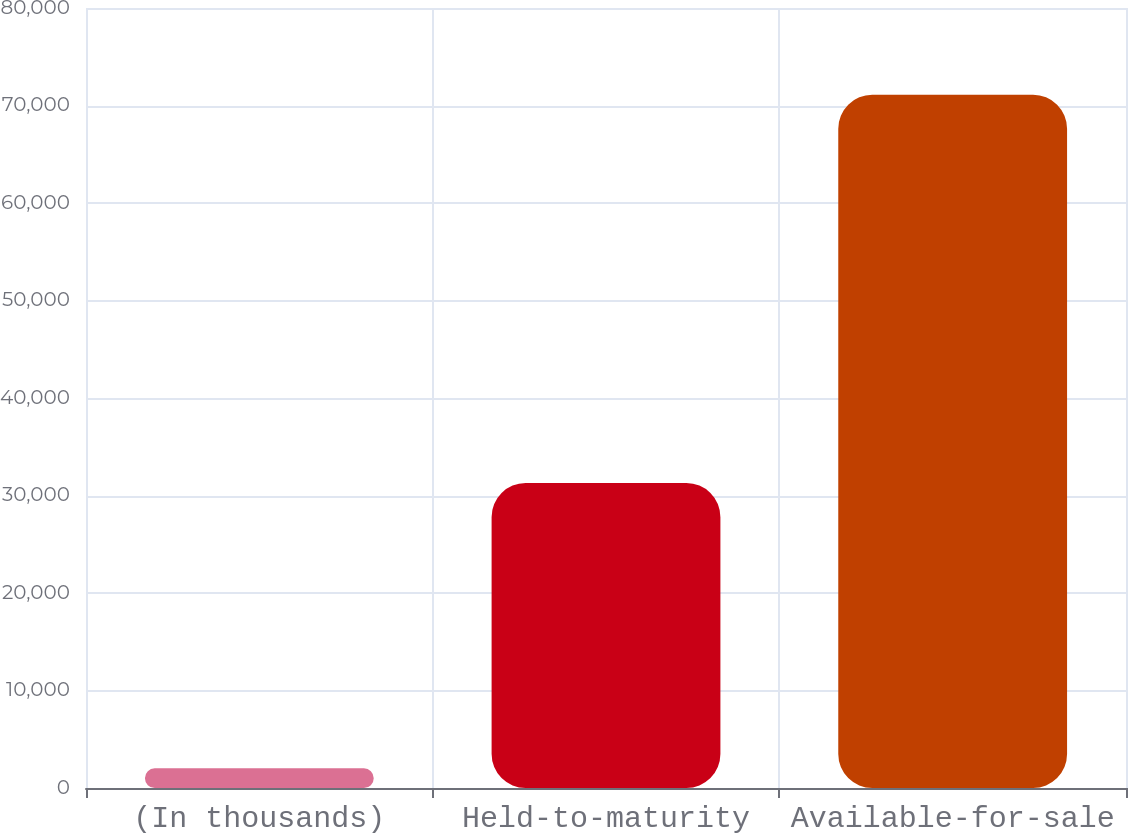Convert chart to OTSL. <chart><loc_0><loc_0><loc_500><loc_500><bar_chart><fcel>(In thousands)<fcel>Held-to-maturity<fcel>Available-for-sale<nl><fcel>2013<fcel>31280<fcel>71107<nl></chart> 